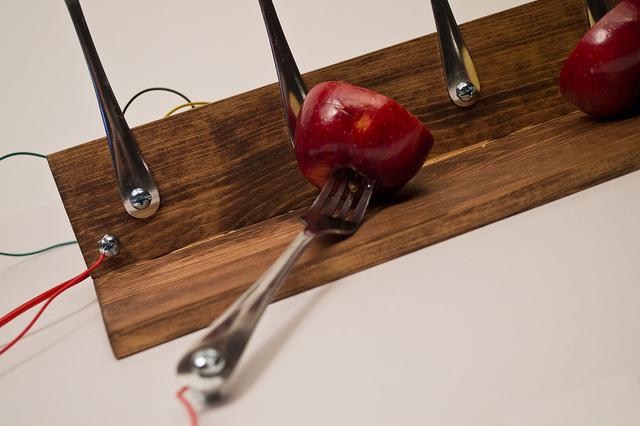What is the fork stuck in?
Keep it brief. Apple. What is the purpose of wiring a fork to an apple?
Answer briefly. Complete circuit. What material are the forks screwed into?
Quick response, please. Wood. 